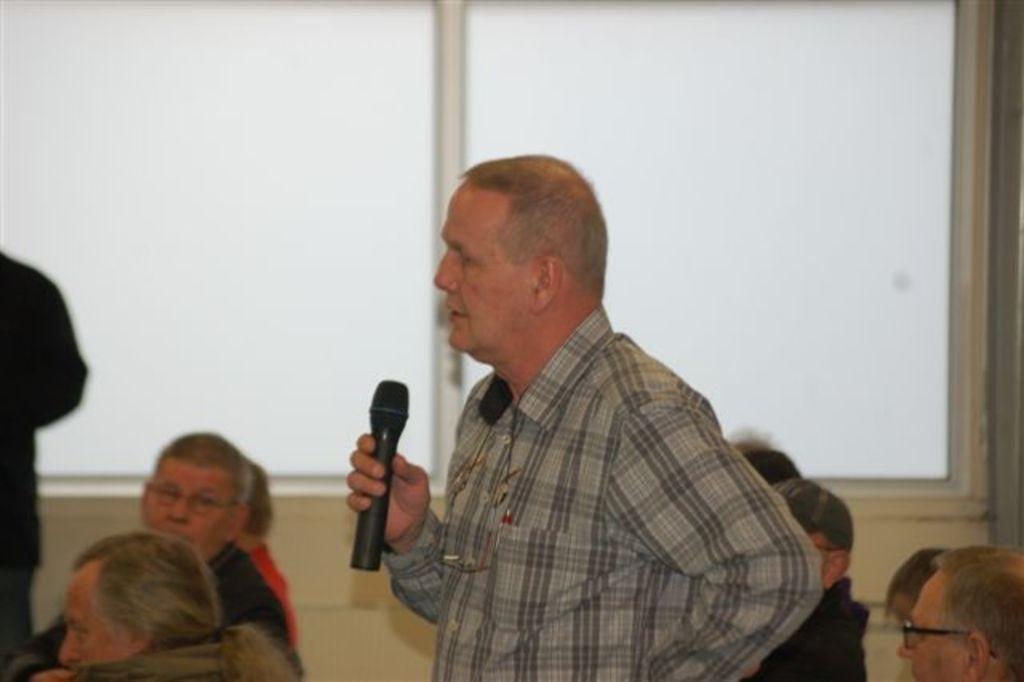What are the people in the image doing? The people in the image are sitting on chairs. Is there anyone standing in the image? Yes, there is a person standing in the image. What is the standing person holding? The standing person is holding a microphone. What is the standing person doing with the microphone? The standing person is talking. What type of writing can be seen on the receipt in the image? There is no receipt present in the image. 